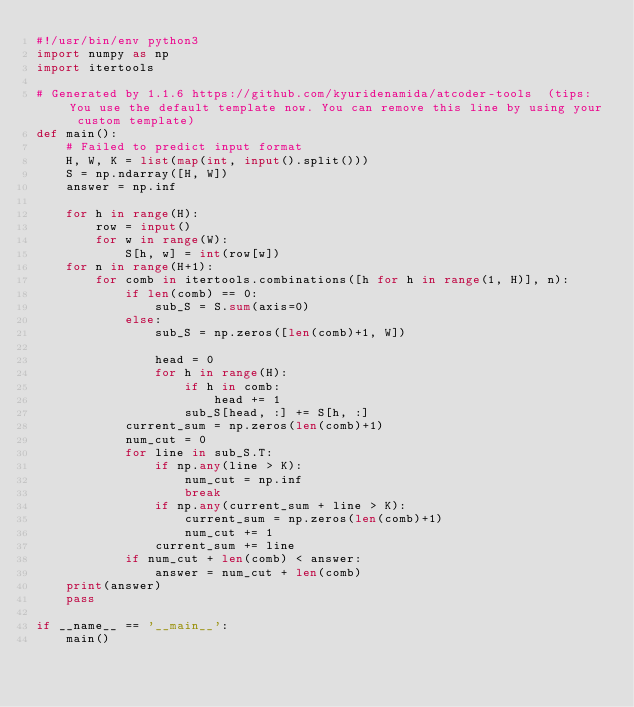<code> <loc_0><loc_0><loc_500><loc_500><_Python_>#!/usr/bin/env python3
import numpy as np
import itertools

# Generated by 1.1.6 https://github.com/kyuridenamida/atcoder-tools  (tips: You use the default template now. You can remove this line by using your custom template)
def main():
    # Failed to predict input format
    H, W, K = list(map(int, input().split()))
    S = np.ndarray([H, W])
    answer = np.inf

    for h in range(H):
        row = input()
        for w in range(W):
            S[h, w] = int(row[w])
    for n in range(H+1):
        for comb in itertools.combinations([h for h in range(1, H)], n):
            if len(comb) == 0:
                sub_S = S.sum(axis=0)
            else:
                sub_S = np.zeros([len(comb)+1, W])

                head = 0
                for h in range(H):
                    if h in comb:
                        head += 1
                    sub_S[head, :] += S[h, :]
            current_sum = np.zeros(len(comb)+1)
            num_cut = 0
            for line in sub_S.T:
                if np.any(line > K):
                    num_cut = np.inf
                    break
                if np.any(current_sum + line > K):
                    current_sum = np.zeros(len(comb)+1)
                    num_cut += 1
                current_sum += line
            if num_cut + len(comb) < answer:
                answer = num_cut + len(comb)
    print(answer)
    pass

if __name__ == '__main__':
    main()
</code> 